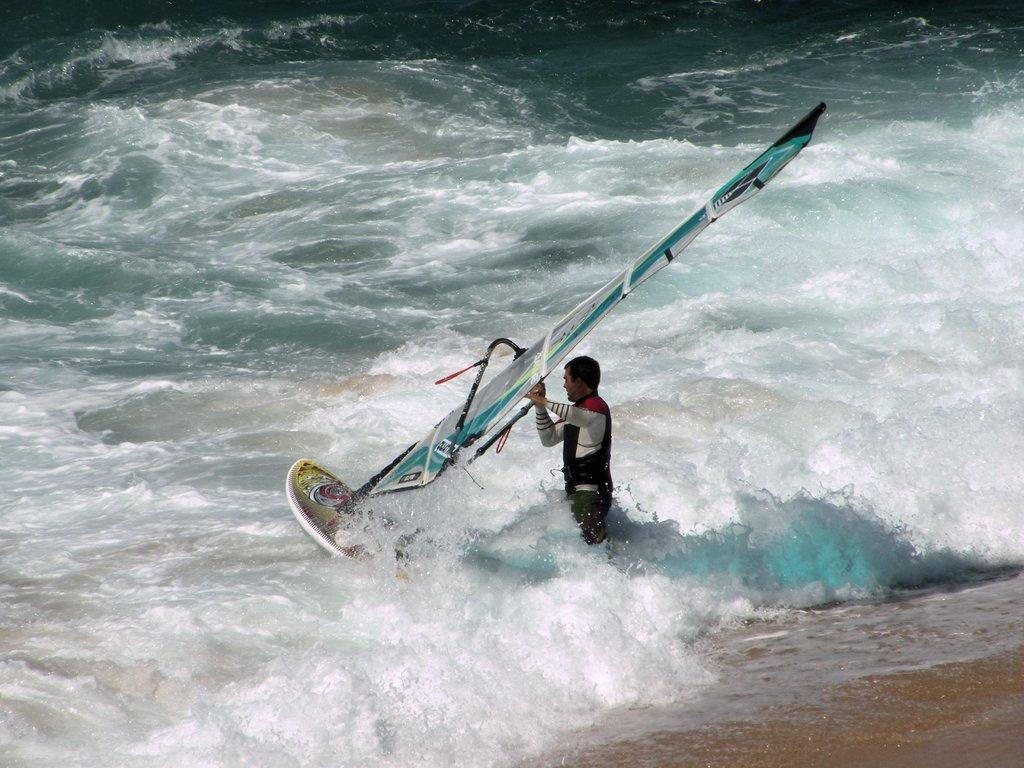Who or what is present in the image? There is a person in the image. What is the person doing in the image? The person is standing in water and holding a surfboard. What can be seen in the background of the image? There is water and sand visible in the background. Where is the donkey sitting in the image? There is no donkey present in the image. 